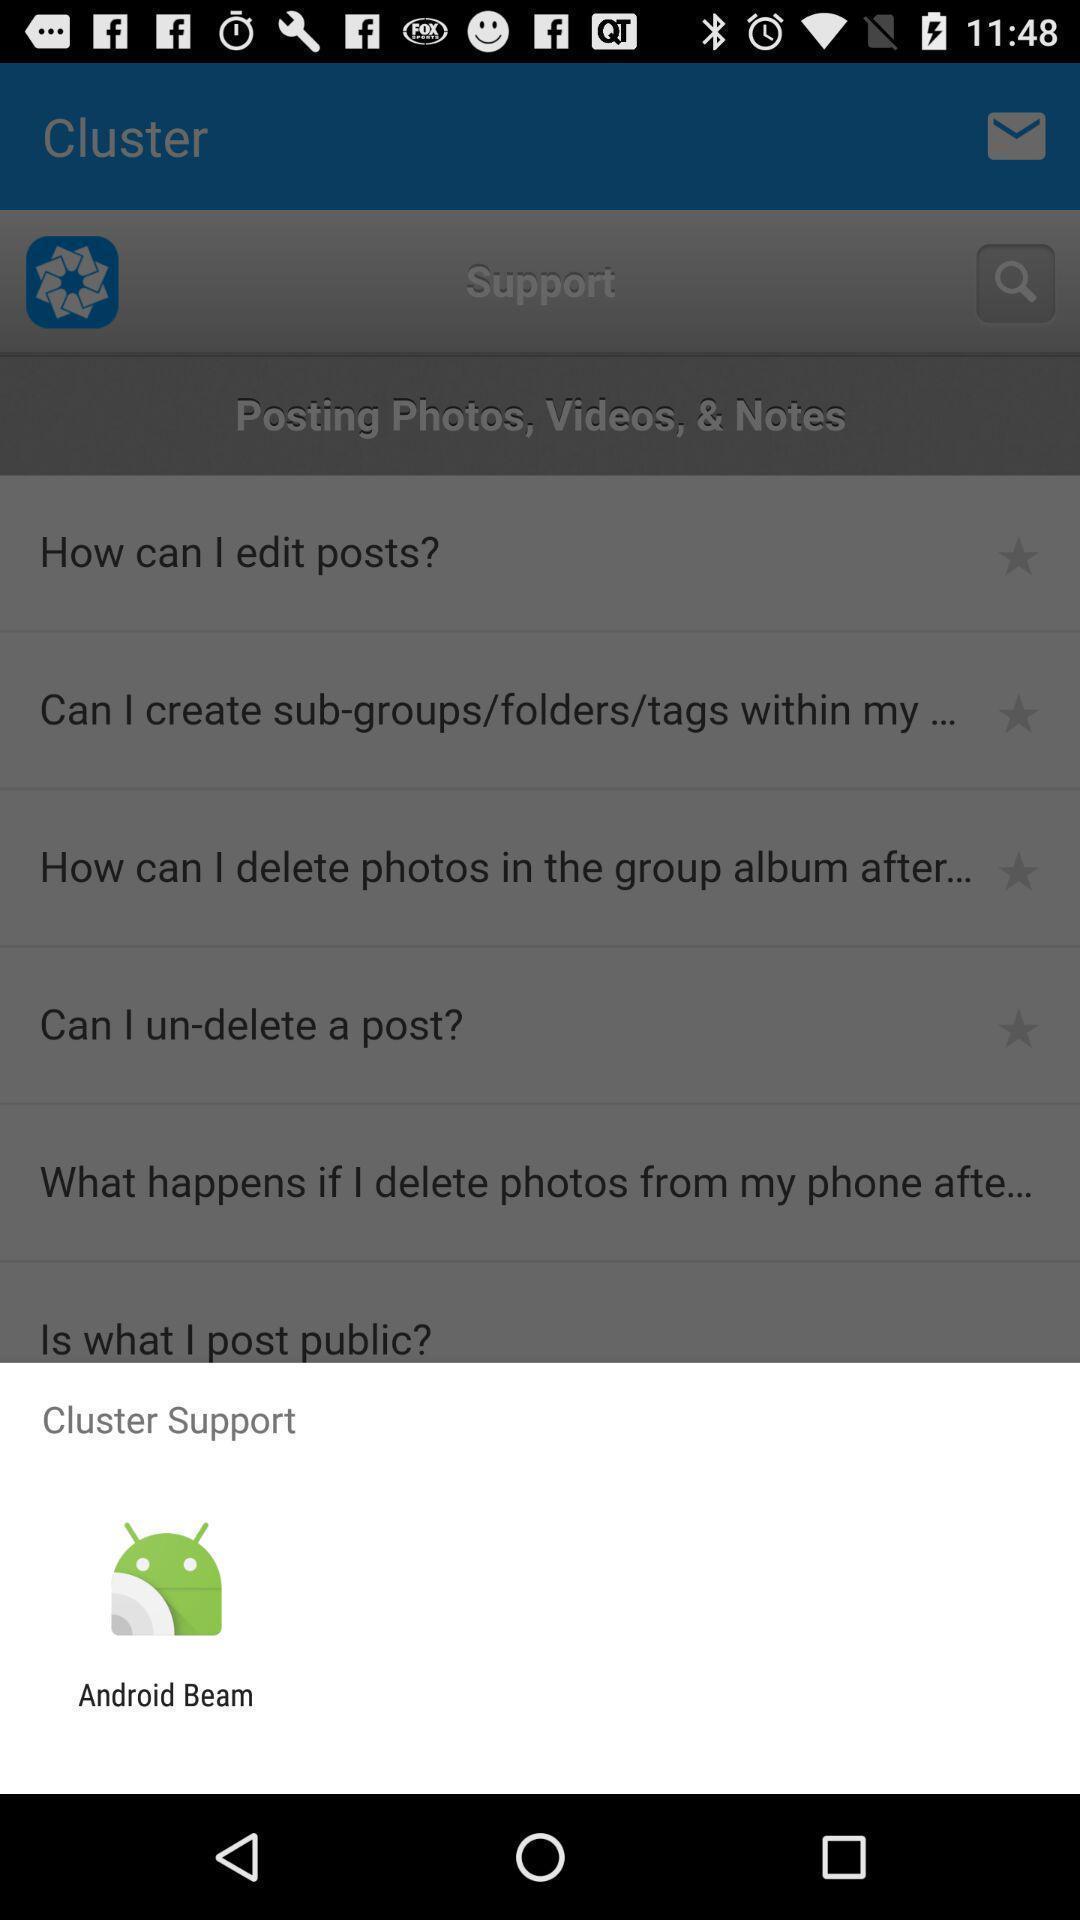Provide a description of this screenshot. Popup for the social app. 